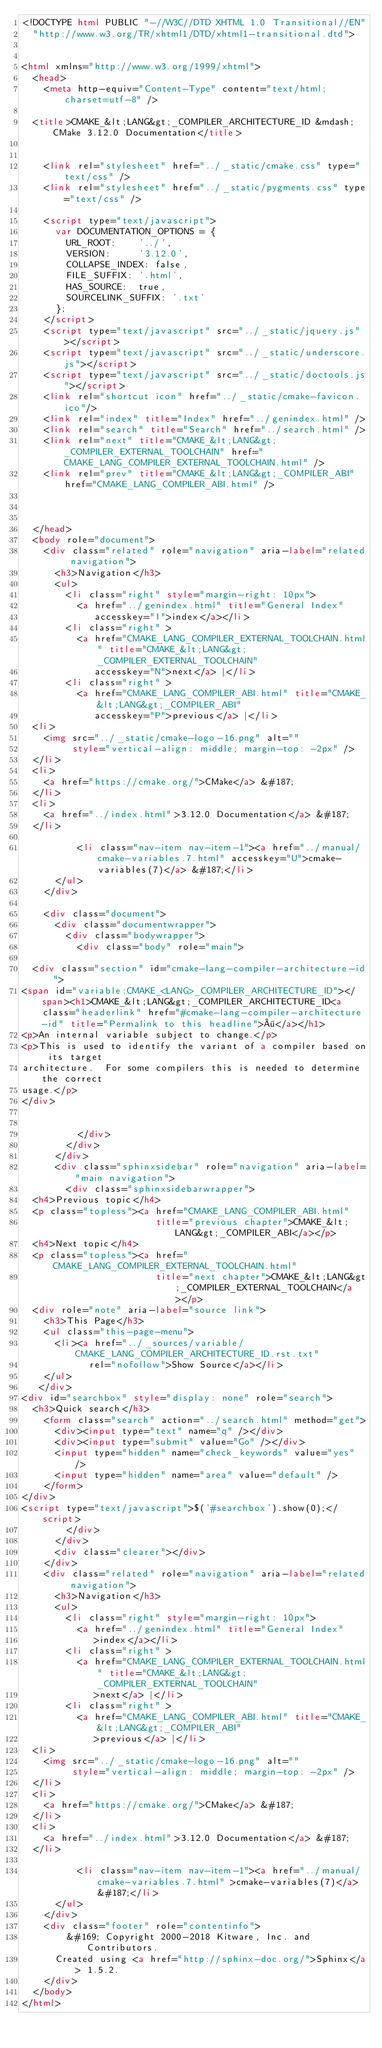Convert code to text. <code><loc_0><loc_0><loc_500><loc_500><_HTML_><!DOCTYPE html PUBLIC "-//W3C//DTD XHTML 1.0 Transitional//EN"
  "http://www.w3.org/TR/xhtml1/DTD/xhtml1-transitional.dtd">


<html xmlns="http://www.w3.org/1999/xhtml">
  <head>
    <meta http-equiv="Content-Type" content="text/html; charset=utf-8" />
    
  <title>CMAKE_&lt;LANG&gt;_COMPILER_ARCHITECTURE_ID &mdash; CMake 3.12.0 Documentation</title>

    
    <link rel="stylesheet" href="../_static/cmake.css" type="text/css" />
    <link rel="stylesheet" href="../_static/pygments.css" type="text/css" />
    
    <script type="text/javascript">
      var DOCUMENTATION_OPTIONS = {
        URL_ROOT:    '../',
        VERSION:     '3.12.0',
        COLLAPSE_INDEX: false,
        FILE_SUFFIX: '.html',
        HAS_SOURCE:  true,
        SOURCELINK_SUFFIX: '.txt'
      };
    </script>
    <script type="text/javascript" src="../_static/jquery.js"></script>
    <script type="text/javascript" src="../_static/underscore.js"></script>
    <script type="text/javascript" src="../_static/doctools.js"></script>
    <link rel="shortcut icon" href="../_static/cmake-favicon.ico"/>
    <link rel="index" title="Index" href="../genindex.html" />
    <link rel="search" title="Search" href="../search.html" />
    <link rel="next" title="CMAKE_&lt;LANG&gt;_COMPILER_EXTERNAL_TOOLCHAIN" href="CMAKE_LANG_COMPILER_EXTERNAL_TOOLCHAIN.html" />
    <link rel="prev" title="CMAKE_&lt;LANG&gt;_COMPILER_ABI" href="CMAKE_LANG_COMPILER_ABI.html" />
  
 

  </head>
  <body role="document">
    <div class="related" role="navigation" aria-label="related navigation">
      <h3>Navigation</h3>
      <ul>
        <li class="right" style="margin-right: 10px">
          <a href="../genindex.html" title="General Index"
             accesskey="I">index</a></li>
        <li class="right" >
          <a href="CMAKE_LANG_COMPILER_EXTERNAL_TOOLCHAIN.html" title="CMAKE_&lt;LANG&gt;_COMPILER_EXTERNAL_TOOLCHAIN"
             accesskey="N">next</a> |</li>
        <li class="right" >
          <a href="CMAKE_LANG_COMPILER_ABI.html" title="CMAKE_&lt;LANG&gt;_COMPILER_ABI"
             accesskey="P">previous</a> |</li>
  <li>
    <img src="../_static/cmake-logo-16.png" alt=""
         style="vertical-align: middle; margin-top: -2px" />
  </li>
  <li>
    <a href="https://cmake.org/">CMake</a> &#187;
  </li>
  <li>
    <a href="../index.html">3.12.0 Documentation</a> &#187;
  </li>

          <li class="nav-item nav-item-1"><a href="../manual/cmake-variables.7.html" accesskey="U">cmake-variables(7)</a> &#187;</li> 
      </ul>
    </div>  

    <div class="document">
      <div class="documentwrapper">
        <div class="bodywrapper">
          <div class="body" role="main">
            
  <div class="section" id="cmake-lang-compiler-architecture-id">
<span id="variable:CMAKE_<LANG>_COMPILER_ARCHITECTURE_ID"></span><h1>CMAKE_&lt;LANG&gt;_COMPILER_ARCHITECTURE_ID<a class="headerlink" href="#cmake-lang-compiler-architecture-id" title="Permalink to this headline">¶</a></h1>
<p>An internal variable subject to change.</p>
<p>This is used to identify the variant of a compiler based on its target
architecture.  For some compilers this is needed to determine the correct
usage.</p>
</div>


          </div>
        </div>
      </div>
      <div class="sphinxsidebar" role="navigation" aria-label="main navigation">
        <div class="sphinxsidebarwrapper">
  <h4>Previous topic</h4>
  <p class="topless"><a href="CMAKE_LANG_COMPILER_ABI.html"
                        title="previous chapter">CMAKE_&lt;LANG&gt;_COMPILER_ABI</a></p>
  <h4>Next topic</h4>
  <p class="topless"><a href="CMAKE_LANG_COMPILER_EXTERNAL_TOOLCHAIN.html"
                        title="next chapter">CMAKE_&lt;LANG&gt;_COMPILER_EXTERNAL_TOOLCHAIN</a></p>
  <div role="note" aria-label="source link">
    <h3>This Page</h3>
    <ul class="this-page-menu">
      <li><a href="../_sources/variable/CMAKE_LANG_COMPILER_ARCHITECTURE_ID.rst.txt"
            rel="nofollow">Show Source</a></li>
    </ul>
   </div>
<div id="searchbox" style="display: none" role="search">
  <h3>Quick search</h3>
    <form class="search" action="../search.html" method="get">
      <div><input type="text" name="q" /></div>
      <div><input type="submit" value="Go" /></div>
      <input type="hidden" name="check_keywords" value="yes" />
      <input type="hidden" name="area" value="default" />
    </form>
</div>
<script type="text/javascript">$('#searchbox').show(0);</script>
        </div>
      </div>
      <div class="clearer"></div>
    </div>
    <div class="related" role="navigation" aria-label="related navigation">
      <h3>Navigation</h3>
      <ul>
        <li class="right" style="margin-right: 10px">
          <a href="../genindex.html" title="General Index"
             >index</a></li>
        <li class="right" >
          <a href="CMAKE_LANG_COMPILER_EXTERNAL_TOOLCHAIN.html" title="CMAKE_&lt;LANG&gt;_COMPILER_EXTERNAL_TOOLCHAIN"
             >next</a> |</li>
        <li class="right" >
          <a href="CMAKE_LANG_COMPILER_ABI.html" title="CMAKE_&lt;LANG&gt;_COMPILER_ABI"
             >previous</a> |</li>
  <li>
    <img src="../_static/cmake-logo-16.png" alt=""
         style="vertical-align: middle; margin-top: -2px" />
  </li>
  <li>
    <a href="https://cmake.org/">CMake</a> &#187;
  </li>
  <li>
    <a href="../index.html">3.12.0 Documentation</a> &#187;
  </li>

          <li class="nav-item nav-item-1"><a href="../manual/cmake-variables.7.html" >cmake-variables(7)</a> &#187;</li> 
      </ul>
    </div>
    <div class="footer" role="contentinfo">
        &#169; Copyright 2000-2018 Kitware, Inc. and Contributors.
      Created using <a href="http://sphinx-doc.org/">Sphinx</a> 1.5.2.
    </div>
  </body>
</html></code> 